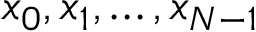Convert formula to latex. <formula><loc_0><loc_0><loc_500><loc_500>x _ { 0 } , x _ { 1 } , \dots , x _ { N - 1 }</formula> 